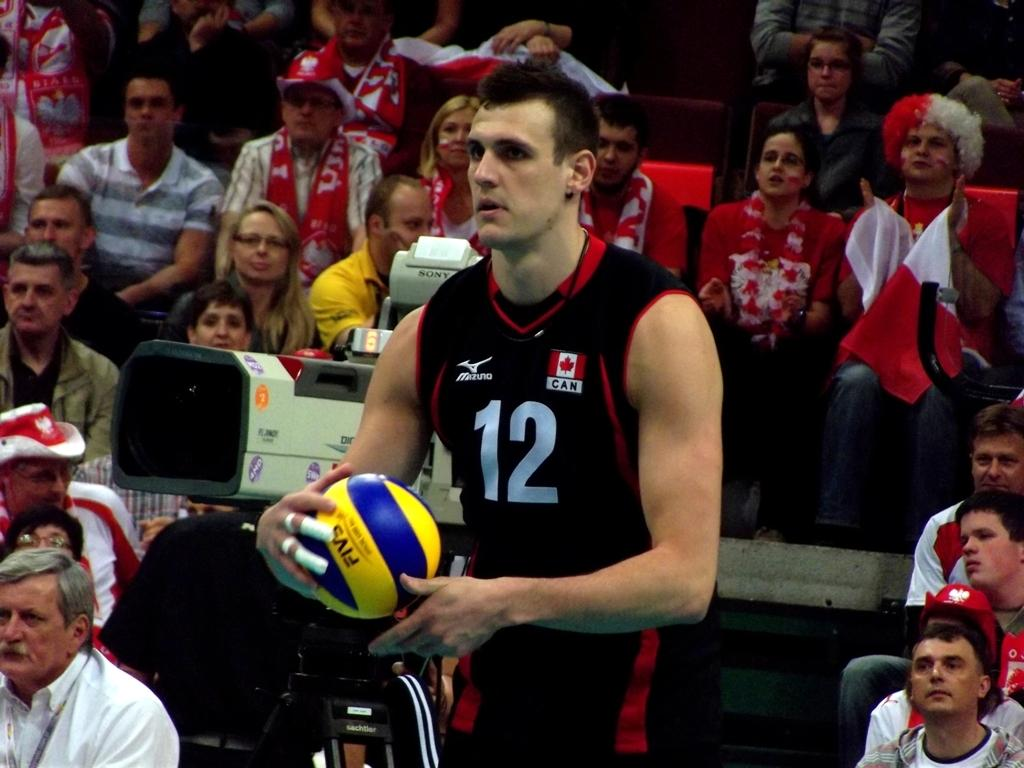What is the main subject of the image? There is a man standing in the center of the image. What is the man holding in his hand? The man is holding a ball in his hand. Can you describe the people in the background of the image? There are people sitting in the background of the image. What type of food is the man eating in the image? There is no food present in the image; the man is holding a ball. Is there any shade provided in the image? The provided facts do not mention any shade in the image. 